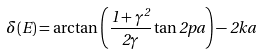Convert formula to latex. <formula><loc_0><loc_0><loc_500><loc_500>\delta ( E ) = \arctan \left ( \frac { 1 + \gamma ^ { 2 } } { 2 \gamma } \tan 2 p a \right ) - 2 k a</formula> 